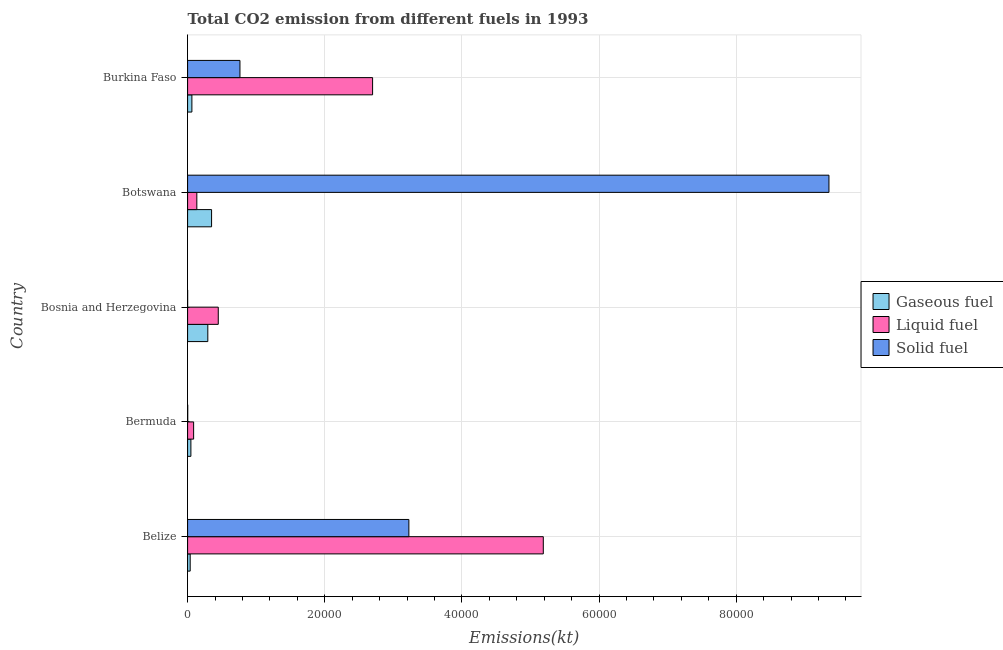How many different coloured bars are there?
Offer a terse response. 3. Are the number of bars per tick equal to the number of legend labels?
Give a very brief answer. Yes. Are the number of bars on each tick of the Y-axis equal?
Make the answer very short. Yes. What is the label of the 5th group of bars from the top?
Provide a short and direct response. Belize. What is the amount of co2 emissions from solid fuel in Botswana?
Provide a short and direct response. 9.35e+04. Across all countries, what is the maximum amount of co2 emissions from liquid fuel?
Your answer should be very brief. 5.19e+04. Across all countries, what is the minimum amount of co2 emissions from liquid fuel?
Provide a succinct answer. 880.08. In which country was the amount of co2 emissions from solid fuel maximum?
Offer a terse response. Botswana. In which country was the amount of co2 emissions from gaseous fuel minimum?
Your answer should be very brief. Belize. What is the total amount of co2 emissions from solid fuel in the graph?
Your answer should be compact. 1.33e+05. What is the difference between the amount of co2 emissions from solid fuel in Bermuda and that in Burkina Faso?
Your answer should be compact. -7616.36. What is the difference between the amount of co2 emissions from gaseous fuel in Botswana and the amount of co2 emissions from solid fuel in Bosnia and Herzegovina?
Provide a succinct answer. 3494.65. What is the average amount of co2 emissions from gaseous fuel per country?
Keep it short and to the point. 1586.34. What is the difference between the amount of co2 emissions from gaseous fuel and amount of co2 emissions from liquid fuel in Burkina Faso?
Your answer should be compact. -2.64e+04. In how many countries, is the amount of co2 emissions from solid fuel greater than 32000 kt?
Ensure brevity in your answer.  2. What is the ratio of the amount of co2 emissions from gaseous fuel in Bermuda to that in Burkina Faso?
Give a very brief answer. 0.77. Is the difference between the amount of co2 emissions from solid fuel in Bosnia and Herzegovina and Burkina Faso greater than the difference between the amount of co2 emissions from gaseous fuel in Bosnia and Herzegovina and Burkina Faso?
Provide a short and direct response. No. What is the difference between the highest and the second highest amount of co2 emissions from gaseous fuel?
Your answer should be very brief. 550.05. What is the difference between the highest and the lowest amount of co2 emissions from liquid fuel?
Make the answer very short. 5.10e+04. What does the 1st bar from the top in Bermuda represents?
Offer a terse response. Solid fuel. What does the 3rd bar from the bottom in Bosnia and Herzegovina represents?
Your answer should be very brief. Solid fuel. Is it the case that in every country, the sum of the amount of co2 emissions from gaseous fuel and amount of co2 emissions from liquid fuel is greater than the amount of co2 emissions from solid fuel?
Ensure brevity in your answer.  No. How many bars are there?
Your answer should be very brief. 15. Are all the bars in the graph horizontal?
Provide a short and direct response. Yes. How many countries are there in the graph?
Offer a terse response. 5. Does the graph contain any zero values?
Offer a terse response. No. Where does the legend appear in the graph?
Offer a very short reply. Center right. How many legend labels are there?
Ensure brevity in your answer.  3. What is the title of the graph?
Ensure brevity in your answer.  Total CO2 emission from different fuels in 1993. Does "Industry" appear as one of the legend labels in the graph?
Ensure brevity in your answer.  No. What is the label or title of the X-axis?
Keep it short and to the point. Emissions(kt). What is the Emissions(kt) of Gaseous fuel in Belize?
Give a very brief answer. 377.7. What is the Emissions(kt) in Liquid fuel in Belize?
Offer a very short reply. 5.19e+04. What is the Emissions(kt) of Solid fuel in Belize?
Make the answer very short. 3.23e+04. What is the Emissions(kt) in Gaseous fuel in Bermuda?
Give a very brief answer. 480.38. What is the Emissions(kt) of Liquid fuel in Bermuda?
Give a very brief answer. 880.08. What is the Emissions(kt) of Solid fuel in Bermuda?
Provide a succinct answer. 18.34. What is the Emissions(kt) in Gaseous fuel in Bosnia and Herzegovina?
Your response must be concise. 2948.27. What is the Emissions(kt) of Liquid fuel in Bosnia and Herzegovina?
Ensure brevity in your answer.  4473.74. What is the Emissions(kt) in Solid fuel in Bosnia and Herzegovina?
Keep it short and to the point. 3.67. What is the Emissions(kt) of Gaseous fuel in Botswana?
Your answer should be very brief. 3498.32. What is the Emissions(kt) in Liquid fuel in Botswana?
Offer a terse response. 1345.79. What is the Emissions(kt) in Solid fuel in Botswana?
Ensure brevity in your answer.  9.35e+04. What is the Emissions(kt) in Gaseous fuel in Burkina Faso?
Offer a terse response. 627.06. What is the Emissions(kt) of Liquid fuel in Burkina Faso?
Your response must be concise. 2.70e+04. What is the Emissions(kt) in Solid fuel in Burkina Faso?
Your answer should be compact. 7634.69. Across all countries, what is the maximum Emissions(kt) in Gaseous fuel?
Offer a very short reply. 3498.32. Across all countries, what is the maximum Emissions(kt) of Liquid fuel?
Provide a short and direct response. 5.19e+04. Across all countries, what is the maximum Emissions(kt) of Solid fuel?
Provide a succinct answer. 9.35e+04. Across all countries, what is the minimum Emissions(kt) of Gaseous fuel?
Keep it short and to the point. 377.7. Across all countries, what is the minimum Emissions(kt) in Liquid fuel?
Your response must be concise. 880.08. Across all countries, what is the minimum Emissions(kt) of Solid fuel?
Provide a succinct answer. 3.67. What is the total Emissions(kt) of Gaseous fuel in the graph?
Your response must be concise. 7931.72. What is the total Emissions(kt) of Liquid fuel in the graph?
Make the answer very short. 8.56e+04. What is the total Emissions(kt) in Solid fuel in the graph?
Provide a succinct answer. 1.33e+05. What is the difference between the Emissions(kt) of Gaseous fuel in Belize and that in Bermuda?
Provide a short and direct response. -102.68. What is the difference between the Emissions(kt) of Liquid fuel in Belize and that in Bermuda?
Your response must be concise. 5.10e+04. What is the difference between the Emissions(kt) in Solid fuel in Belize and that in Bermuda?
Keep it short and to the point. 3.23e+04. What is the difference between the Emissions(kt) of Gaseous fuel in Belize and that in Bosnia and Herzegovina?
Provide a succinct answer. -2570.57. What is the difference between the Emissions(kt) in Liquid fuel in Belize and that in Bosnia and Herzegovina?
Offer a very short reply. 4.74e+04. What is the difference between the Emissions(kt) in Solid fuel in Belize and that in Bosnia and Herzegovina?
Your answer should be very brief. 3.23e+04. What is the difference between the Emissions(kt) of Gaseous fuel in Belize and that in Botswana?
Ensure brevity in your answer.  -3120.62. What is the difference between the Emissions(kt) of Liquid fuel in Belize and that in Botswana?
Your answer should be compact. 5.05e+04. What is the difference between the Emissions(kt) of Solid fuel in Belize and that in Botswana?
Your answer should be very brief. -6.13e+04. What is the difference between the Emissions(kt) of Gaseous fuel in Belize and that in Burkina Faso?
Your answer should be compact. -249.36. What is the difference between the Emissions(kt) in Liquid fuel in Belize and that in Burkina Faso?
Your answer should be compact. 2.49e+04. What is the difference between the Emissions(kt) of Solid fuel in Belize and that in Burkina Faso?
Provide a short and direct response. 2.46e+04. What is the difference between the Emissions(kt) in Gaseous fuel in Bermuda and that in Bosnia and Herzegovina?
Ensure brevity in your answer.  -2467.89. What is the difference between the Emissions(kt) in Liquid fuel in Bermuda and that in Bosnia and Herzegovina?
Make the answer very short. -3593.66. What is the difference between the Emissions(kt) of Solid fuel in Bermuda and that in Bosnia and Herzegovina?
Give a very brief answer. 14.67. What is the difference between the Emissions(kt) of Gaseous fuel in Bermuda and that in Botswana?
Your answer should be compact. -3017.94. What is the difference between the Emissions(kt) in Liquid fuel in Bermuda and that in Botswana?
Offer a very short reply. -465.71. What is the difference between the Emissions(kt) in Solid fuel in Bermuda and that in Botswana?
Your answer should be very brief. -9.35e+04. What is the difference between the Emissions(kt) in Gaseous fuel in Bermuda and that in Burkina Faso?
Provide a succinct answer. -146.68. What is the difference between the Emissions(kt) in Liquid fuel in Bermuda and that in Burkina Faso?
Your response must be concise. -2.61e+04. What is the difference between the Emissions(kt) in Solid fuel in Bermuda and that in Burkina Faso?
Provide a short and direct response. -7616.36. What is the difference between the Emissions(kt) of Gaseous fuel in Bosnia and Herzegovina and that in Botswana?
Offer a very short reply. -550.05. What is the difference between the Emissions(kt) of Liquid fuel in Bosnia and Herzegovina and that in Botswana?
Your answer should be compact. 3127.95. What is the difference between the Emissions(kt) in Solid fuel in Bosnia and Herzegovina and that in Botswana?
Provide a short and direct response. -9.35e+04. What is the difference between the Emissions(kt) in Gaseous fuel in Bosnia and Herzegovina and that in Burkina Faso?
Make the answer very short. 2321.21. What is the difference between the Emissions(kt) of Liquid fuel in Bosnia and Herzegovina and that in Burkina Faso?
Your response must be concise. -2.25e+04. What is the difference between the Emissions(kt) of Solid fuel in Bosnia and Herzegovina and that in Burkina Faso?
Provide a succinct answer. -7631.03. What is the difference between the Emissions(kt) in Gaseous fuel in Botswana and that in Burkina Faso?
Provide a short and direct response. 2871.26. What is the difference between the Emissions(kt) of Liquid fuel in Botswana and that in Burkina Faso?
Make the answer very short. -2.56e+04. What is the difference between the Emissions(kt) in Solid fuel in Botswana and that in Burkina Faso?
Ensure brevity in your answer.  8.59e+04. What is the difference between the Emissions(kt) in Gaseous fuel in Belize and the Emissions(kt) in Liquid fuel in Bermuda?
Offer a terse response. -502.38. What is the difference between the Emissions(kt) of Gaseous fuel in Belize and the Emissions(kt) of Solid fuel in Bermuda?
Offer a terse response. 359.37. What is the difference between the Emissions(kt) of Liquid fuel in Belize and the Emissions(kt) of Solid fuel in Bermuda?
Your answer should be compact. 5.19e+04. What is the difference between the Emissions(kt) in Gaseous fuel in Belize and the Emissions(kt) in Liquid fuel in Bosnia and Herzegovina?
Your answer should be very brief. -4096.04. What is the difference between the Emissions(kt) of Gaseous fuel in Belize and the Emissions(kt) of Solid fuel in Bosnia and Herzegovina?
Offer a very short reply. 374.03. What is the difference between the Emissions(kt) of Liquid fuel in Belize and the Emissions(kt) of Solid fuel in Bosnia and Herzegovina?
Your answer should be compact. 5.19e+04. What is the difference between the Emissions(kt) in Gaseous fuel in Belize and the Emissions(kt) in Liquid fuel in Botswana?
Your answer should be compact. -968.09. What is the difference between the Emissions(kt) in Gaseous fuel in Belize and the Emissions(kt) in Solid fuel in Botswana?
Ensure brevity in your answer.  -9.32e+04. What is the difference between the Emissions(kt) of Liquid fuel in Belize and the Emissions(kt) of Solid fuel in Botswana?
Ensure brevity in your answer.  -4.17e+04. What is the difference between the Emissions(kt) in Gaseous fuel in Belize and the Emissions(kt) in Liquid fuel in Burkina Faso?
Offer a very short reply. -2.66e+04. What is the difference between the Emissions(kt) in Gaseous fuel in Belize and the Emissions(kt) in Solid fuel in Burkina Faso?
Your answer should be compact. -7256.99. What is the difference between the Emissions(kt) in Liquid fuel in Belize and the Emissions(kt) in Solid fuel in Burkina Faso?
Give a very brief answer. 4.42e+04. What is the difference between the Emissions(kt) of Gaseous fuel in Bermuda and the Emissions(kt) of Liquid fuel in Bosnia and Herzegovina?
Make the answer very short. -3993.36. What is the difference between the Emissions(kt) of Gaseous fuel in Bermuda and the Emissions(kt) of Solid fuel in Bosnia and Herzegovina?
Make the answer very short. 476.71. What is the difference between the Emissions(kt) of Liquid fuel in Bermuda and the Emissions(kt) of Solid fuel in Bosnia and Herzegovina?
Provide a short and direct response. 876.41. What is the difference between the Emissions(kt) in Gaseous fuel in Bermuda and the Emissions(kt) in Liquid fuel in Botswana?
Provide a succinct answer. -865.41. What is the difference between the Emissions(kt) in Gaseous fuel in Bermuda and the Emissions(kt) in Solid fuel in Botswana?
Ensure brevity in your answer.  -9.31e+04. What is the difference between the Emissions(kt) in Liquid fuel in Bermuda and the Emissions(kt) in Solid fuel in Botswana?
Your answer should be compact. -9.27e+04. What is the difference between the Emissions(kt) in Gaseous fuel in Bermuda and the Emissions(kt) in Liquid fuel in Burkina Faso?
Give a very brief answer. -2.65e+04. What is the difference between the Emissions(kt) in Gaseous fuel in Bermuda and the Emissions(kt) in Solid fuel in Burkina Faso?
Provide a succinct answer. -7154.32. What is the difference between the Emissions(kt) in Liquid fuel in Bermuda and the Emissions(kt) in Solid fuel in Burkina Faso?
Offer a very short reply. -6754.61. What is the difference between the Emissions(kt) in Gaseous fuel in Bosnia and Herzegovina and the Emissions(kt) in Liquid fuel in Botswana?
Offer a very short reply. 1602.48. What is the difference between the Emissions(kt) in Gaseous fuel in Bosnia and Herzegovina and the Emissions(kt) in Solid fuel in Botswana?
Your answer should be compact. -9.06e+04. What is the difference between the Emissions(kt) of Liquid fuel in Bosnia and Herzegovina and the Emissions(kt) of Solid fuel in Botswana?
Provide a succinct answer. -8.91e+04. What is the difference between the Emissions(kt) of Gaseous fuel in Bosnia and Herzegovina and the Emissions(kt) of Liquid fuel in Burkina Faso?
Offer a very short reply. -2.40e+04. What is the difference between the Emissions(kt) of Gaseous fuel in Bosnia and Herzegovina and the Emissions(kt) of Solid fuel in Burkina Faso?
Give a very brief answer. -4686.43. What is the difference between the Emissions(kt) of Liquid fuel in Bosnia and Herzegovina and the Emissions(kt) of Solid fuel in Burkina Faso?
Your answer should be compact. -3160.95. What is the difference between the Emissions(kt) of Gaseous fuel in Botswana and the Emissions(kt) of Liquid fuel in Burkina Faso?
Keep it short and to the point. -2.35e+04. What is the difference between the Emissions(kt) of Gaseous fuel in Botswana and the Emissions(kt) of Solid fuel in Burkina Faso?
Your answer should be very brief. -4136.38. What is the difference between the Emissions(kt) in Liquid fuel in Botswana and the Emissions(kt) in Solid fuel in Burkina Faso?
Your answer should be compact. -6288.9. What is the average Emissions(kt) of Gaseous fuel per country?
Your answer should be compact. 1586.34. What is the average Emissions(kt) in Liquid fuel per country?
Ensure brevity in your answer.  1.71e+04. What is the average Emissions(kt) in Solid fuel per country?
Make the answer very short. 2.67e+04. What is the difference between the Emissions(kt) in Gaseous fuel and Emissions(kt) in Liquid fuel in Belize?
Keep it short and to the point. -5.15e+04. What is the difference between the Emissions(kt) in Gaseous fuel and Emissions(kt) in Solid fuel in Belize?
Keep it short and to the point. -3.19e+04. What is the difference between the Emissions(kt) in Liquid fuel and Emissions(kt) in Solid fuel in Belize?
Provide a succinct answer. 1.96e+04. What is the difference between the Emissions(kt) in Gaseous fuel and Emissions(kt) in Liquid fuel in Bermuda?
Your answer should be compact. -399.7. What is the difference between the Emissions(kt) in Gaseous fuel and Emissions(kt) in Solid fuel in Bermuda?
Offer a terse response. 462.04. What is the difference between the Emissions(kt) in Liquid fuel and Emissions(kt) in Solid fuel in Bermuda?
Your answer should be compact. 861.75. What is the difference between the Emissions(kt) in Gaseous fuel and Emissions(kt) in Liquid fuel in Bosnia and Herzegovina?
Make the answer very short. -1525.47. What is the difference between the Emissions(kt) in Gaseous fuel and Emissions(kt) in Solid fuel in Bosnia and Herzegovina?
Offer a very short reply. 2944.6. What is the difference between the Emissions(kt) of Liquid fuel and Emissions(kt) of Solid fuel in Bosnia and Herzegovina?
Ensure brevity in your answer.  4470.07. What is the difference between the Emissions(kt) of Gaseous fuel and Emissions(kt) of Liquid fuel in Botswana?
Offer a very short reply. 2152.53. What is the difference between the Emissions(kt) of Gaseous fuel and Emissions(kt) of Solid fuel in Botswana?
Offer a very short reply. -9.00e+04. What is the difference between the Emissions(kt) in Liquid fuel and Emissions(kt) in Solid fuel in Botswana?
Your answer should be compact. -9.22e+04. What is the difference between the Emissions(kt) of Gaseous fuel and Emissions(kt) of Liquid fuel in Burkina Faso?
Your answer should be very brief. -2.64e+04. What is the difference between the Emissions(kt) of Gaseous fuel and Emissions(kt) of Solid fuel in Burkina Faso?
Keep it short and to the point. -7007.64. What is the difference between the Emissions(kt) of Liquid fuel and Emissions(kt) of Solid fuel in Burkina Faso?
Your answer should be very brief. 1.93e+04. What is the ratio of the Emissions(kt) in Gaseous fuel in Belize to that in Bermuda?
Your answer should be very brief. 0.79. What is the ratio of the Emissions(kt) of Liquid fuel in Belize to that in Bermuda?
Ensure brevity in your answer.  58.94. What is the ratio of the Emissions(kt) in Solid fuel in Belize to that in Bermuda?
Offer a terse response. 1760. What is the ratio of the Emissions(kt) in Gaseous fuel in Belize to that in Bosnia and Herzegovina?
Keep it short and to the point. 0.13. What is the ratio of the Emissions(kt) of Liquid fuel in Belize to that in Bosnia and Herzegovina?
Make the answer very short. 11.6. What is the ratio of the Emissions(kt) in Solid fuel in Belize to that in Bosnia and Herzegovina?
Keep it short and to the point. 8800. What is the ratio of the Emissions(kt) in Gaseous fuel in Belize to that in Botswana?
Give a very brief answer. 0.11. What is the ratio of the Emissions(kt) of Liquid fuel in Belize to that in Botswana?
Give a very brief answer. 38.55. What is the ratio of the Emissions(kt) of Solid fuel in Belize to that in Botswana?
Make the answer very short. 0.34. What is the ratio of the Emissions(kt) of Gaseous fuel in Belize to that in Burkina Faso?
Provide a succinct answer. 0.6. What is the ratio of the Emissions(kt) of Liquid fuel in Belize to that in Burkina Faso?
Keep it short and to the point. 1.92. What is the ratio of the Emissions(kt) in Solid fuel in Belize to that in Burkina Faso?
Provide a short and direct response. 4.23. What is the ratio of the Emissions(kt) of Gaseous fuel in Bermuda to that in Bosnia and Herzegovina?
Your response must be concise. 0.16. What is the ratio of the Emissions(kt) in Liquid fuel in Bermuda to that in Bosnia and Herzegovina?
Make the answer very short. 0.2. What is the ratio of the Emissions(kt) in Solid fuel in Bermuda to that in Bosnia and Herzegovina?
Give a very brief answer. 5. What is the ratio of the Emissions(kt) in Gaseous fuel in Bermuda to that in Botswana?
Make the answer very short. 0.14. What is the ratio of the Emissions(kt) in Liquid fuel in Bermuda to that in Botswana?
Keep it short and to the point. 0.65. What is the ratio of the Emissions(kt) in Gaseous fuel in Bermuda to that in Burkina Faso?
Offer a terse response. 0.77. What is the ratio of the Emissions(kt) in Liquid fuel in Bermuda to that in Burkina Faso?
Your response must be concise. 0.03. What is the ratio of the Emissions(kt) in Solid fuel in Bermuda to that in Burkina Faso?
Offer a terse response. 0. What is the ratio of the Emissions(kt) of Gaseous fuel in Bosnia and Herzegovina to that in Botswana?
Keep it short and to the point. 0.84. What is the ratio of the Emissions(kt) of Liquid fuel in Bosnia and Herzegovina to that in Botswana?
Provide a succinct answer. 3.32. What is the ratio of the Emissions(kt) of Solid fuel in Bosnia and Herzegovina to that in Botswana?
Offer a terse response. 0. What is the ratio of the Emissions(kt) in Gaseous fuel in Bosnia and Herzegovina to that in Burkina Faso?
Ensure brevity in your answer.  4.7. What is the ratio of the Emissions(kt) of Liquid fuel in Bosnia and Herzegovina to that in Burkina Faso?
Offer a very short reply. 0.17. What is the ratio of the Emissions(kt) in Solid fuel in Bosnia and Herzegovina to that in Burkina Faso?
Offer a very short reply. 0. What is the ratio of the Emissions(kt) of Gaseous fuel in Botswana to that in Burkina Faso?
Ensure brevity in your answer.  5.58. What is the ratio of the Emissions(kt) in Liquid fuel in Botswana to that in Burkina Faso?
Keep it short and to the point. 0.05. What is the ratio of the Emissions(kt) of Solid fuel in Botswana to that in Burkina Faso?
Offer a very short reply. 12.25. What is the difference between the highest and the second highest Emissions(kt) in Gaseous fuel?
Keep it short and to the point. 550.05. What is the difference between the highest and the second highest Emissions(kt) in Liquid fuel?
Your answer should be compact. 2.49e+04. What is the difference between the highest and the second highest Emissions(kt) of Solid fuel?
Ensure brevity in your answer.  6.13e+04. What is the difference between the highest and the lowest Emissions(kt) of Gaseous fuel?
Make the answer very short. 3120.62. What is the difference between the highest and the lowest Emissions(kt) in Liquid fuel?
Provide a short and direct response. 5.10e+04. What is the difference between the highest and the lowest Emissions(kt) in Solid fuel?
Provide a succinct answer. 9.35e+04. 